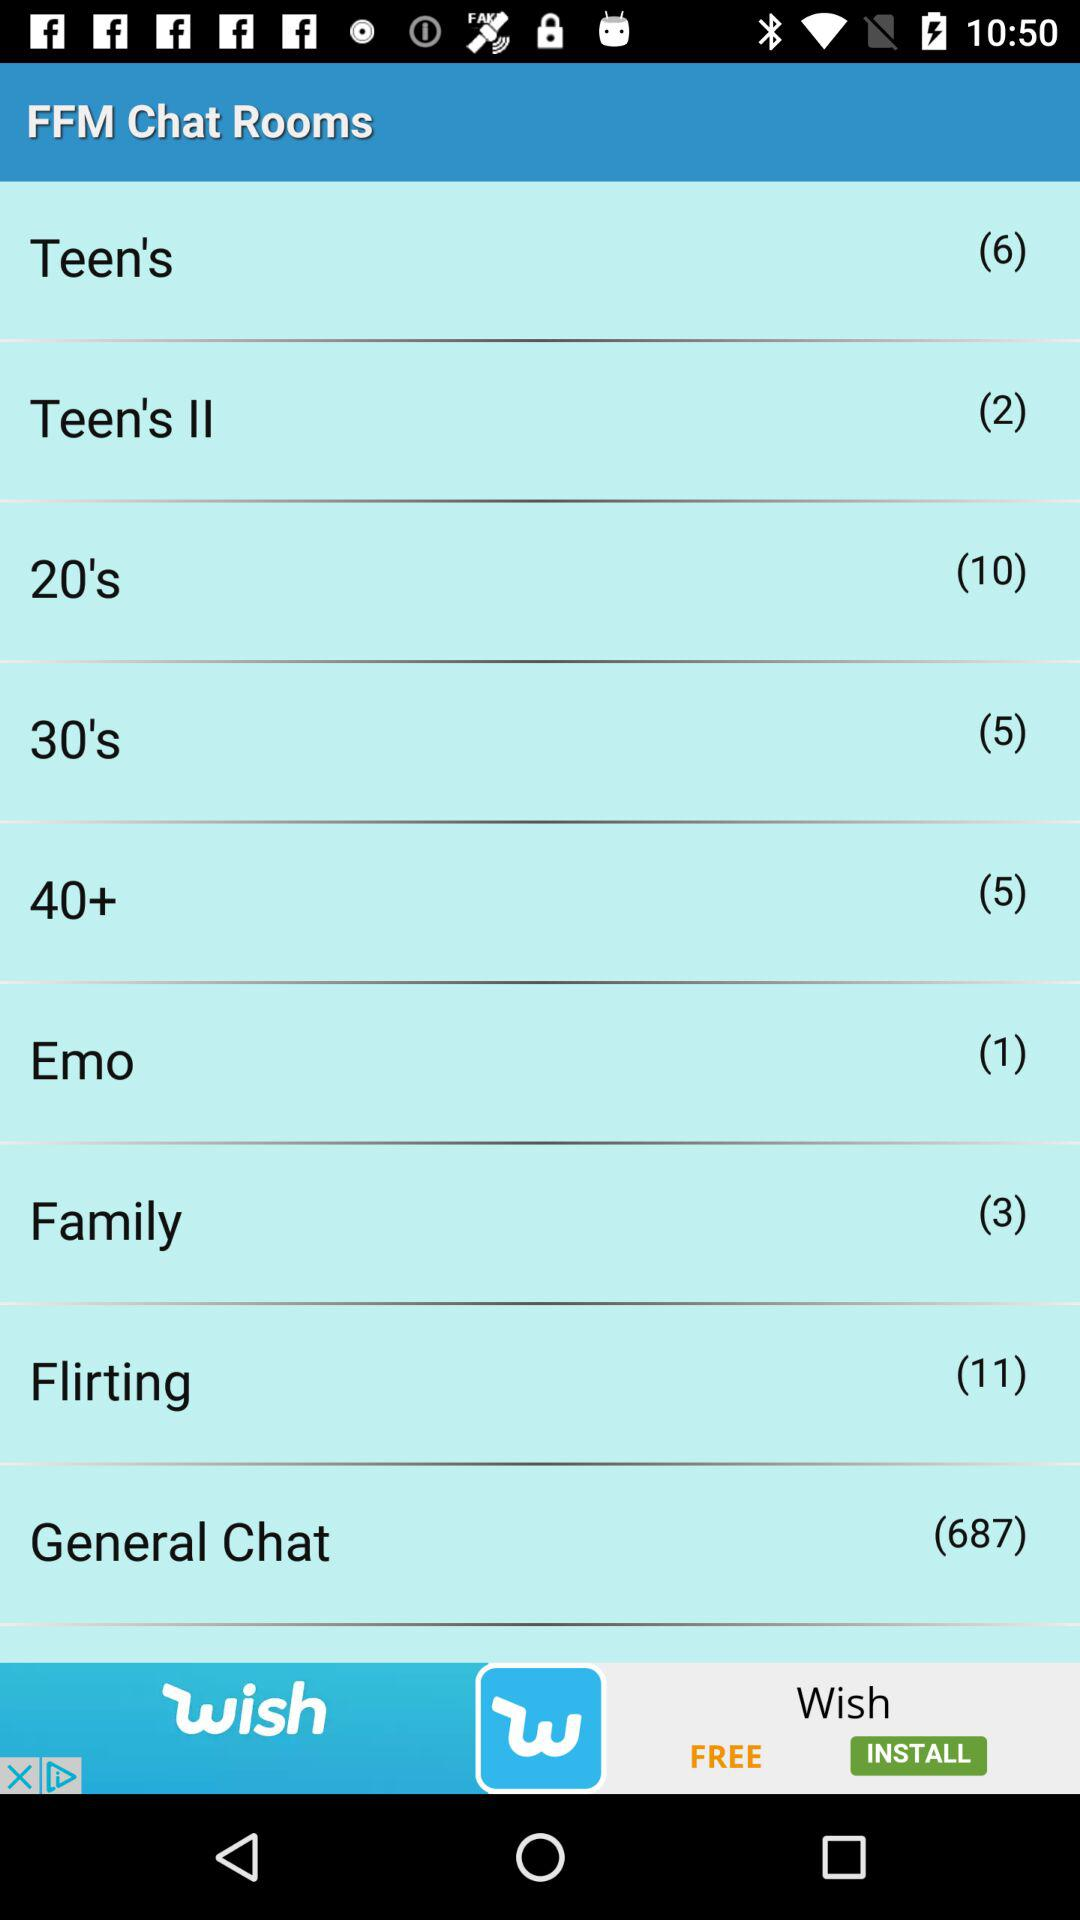Which chat room has 3 members? The chat room that has 3 members is "Family". 